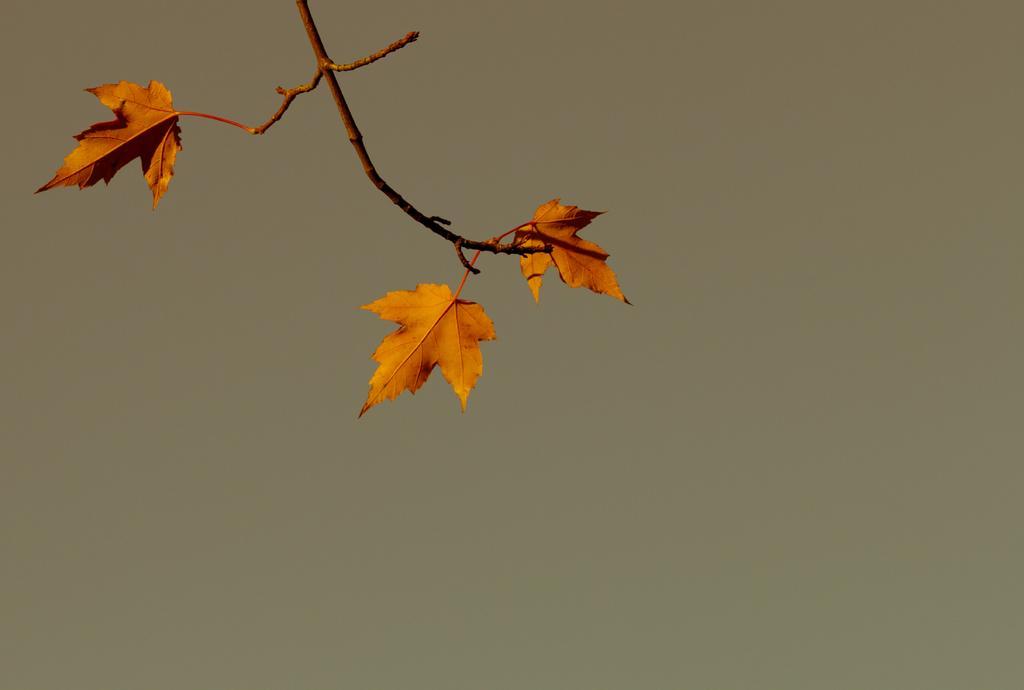Describe this image in one or two sentences. In this picture there is a plant and there are three leaves on the plant. At the back there's a light brown color background. 